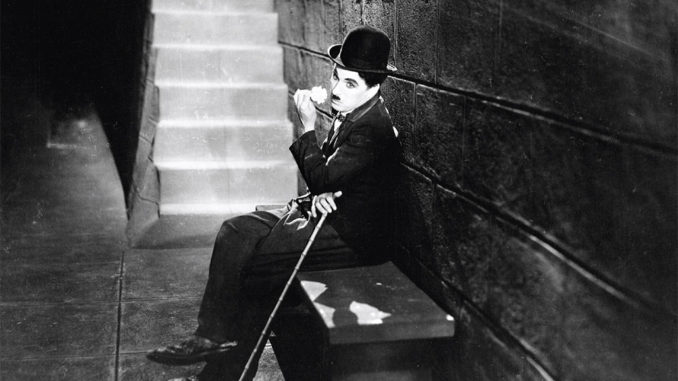Analyze the image in a comprehensive and detailed manner. In this detailed black and white photograph, we observe the iconic silent film legend Charlie Chaplin, portrayed in his timeless character as the Tramp. Seated comfortably on a stone bench, Chaplin's distinct persona is captured in his poised yet thoughtfully relaxed posture. He is clothed in his signature attire—a slightly tattered suit, complemented by a bowler hat, and his characteristic small toothbrush mustache. His reliable cane, a sturdy companion through many of his adventures, rests gently across his lap. The Tramp’s thoughtful gaze is directed towards an unseen object off-camera, suggesting a moment of contemplation or introspection. The backdrop features a neatly arranged stone wall and a staircase that adds depth and context to the scene. The monochromatic scheme of the image accentuates the period’s style and highlights the nostalgic charm that has made Charlie Chaplin an enduring figure in the world of cinema. 